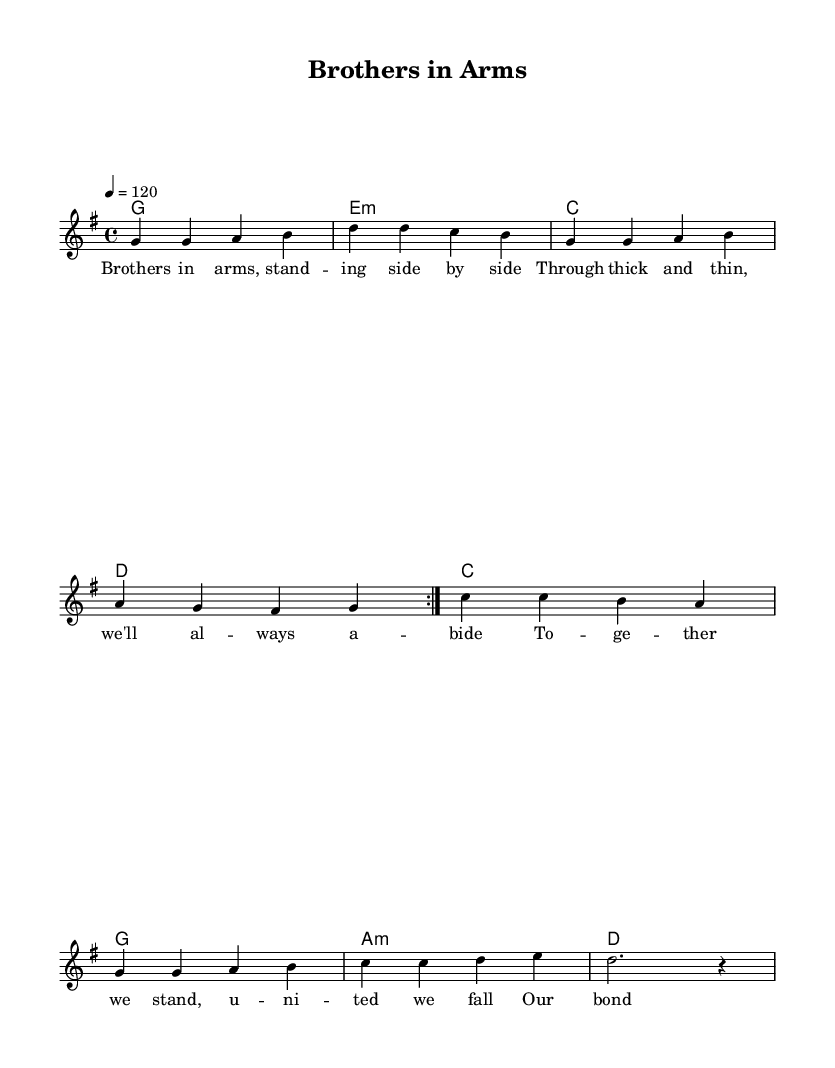What is the key signature of this music? The key signature shown in the sheet music indicates one sharp, which corresponds to G major. This means the pitches of the chord tones will primarily revolve around G major tonality.
Answer: G major What is the time signature of the piece? The time signature is indicated as 4/4, shown at the start of the score, meaning each measure has four beats and the quarter note gets one beat.
Answer: 4/4 What is the tempo indicated for this piece? The tempo marking is specified as a quarter note equals 120 beats per minute, which gives a brisk and lively pace to the performance.
Answer: 120 How many measures are in the melody section? The melody section consists of two repeated sections for a total of eight measures (four in each volta), which can be counted sequentially in the melody line.
Answer: 8 Which chord follows the melody's note G in the first section? After the note G in the melody, the chords specified under it in the harmonies section indicate a G major chord immediately follows. This is observed as the first note of the chord progression.
Answer: G What is the thematic focus of the lyrics in the chorus? The lyrics of the chorus emphasize unity and strength among the soldiers, as highlighted through phrases about standing together and unbroken bonds, which is central to the camaraderie theme in the song.
Answer: Unity 